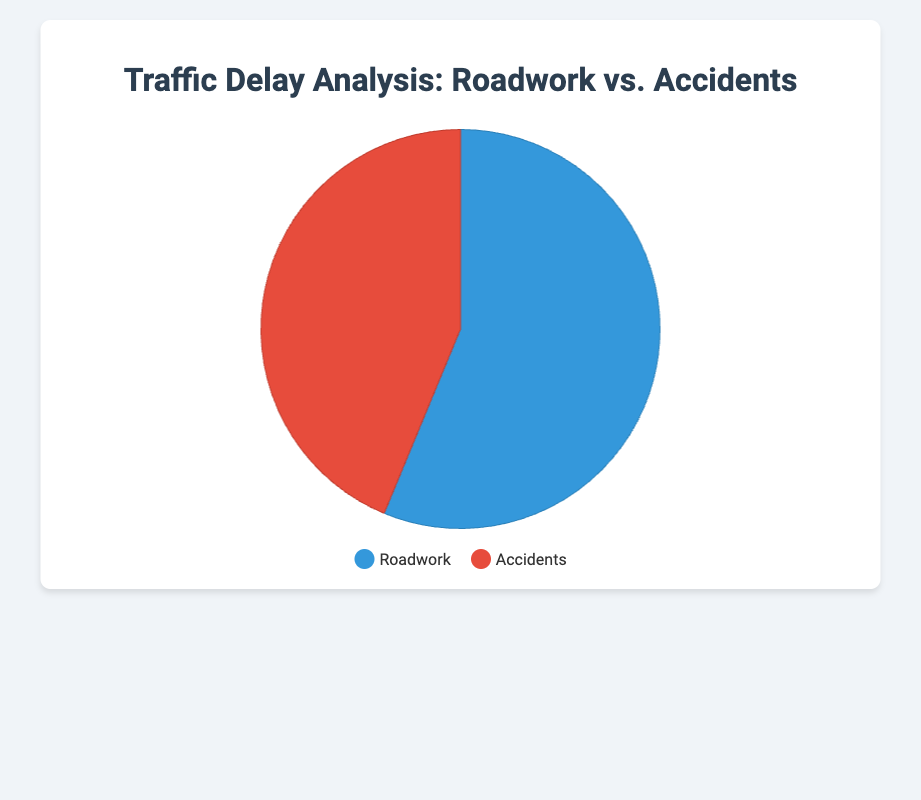What is the total delay caused by roadwork? To find the total delay caused by roadwork, you need to sum the durations for Los Angeles (45 minutes), Chicago (30 minutes), and New York (60 minutes). 45 + 30 + 60 = 135 minutes.
Answer: 135 minutes What is the percentage of delays caused by accidents? First, find the total delay for accidents by summing up the durations for Houston (20 minutes), Phoenix (35 minutes), and San Francisco (50 minutes). 20 + 35 + 50 = 105 minutes. Then, calculate the total delay by adding roadwork (135 minutes) and accidents (105 minutes). 135 + 105 = 240 minutes. Finally, divide the accident delay by the total delay and multiply by 100 to get the percentage: (105 / 240) * 100 = 43.75%.
Answer: 43.75% Which category of delay is larger, roadwork or accidents? Compare the total delays caused by roadwork (135 minutes) and accidents (105 minutes). Since 135 > 105, roadwork causes more delay than accidents.
Answer: Roadwork What is the difference in total delays between roadwork and accidents? Subtract the total delay caused by accidents (105 minutes) from the total delay caused by roadwork (135 minutes). 135 - 105 = 30 minutes.
Answer: 30 minutes If the delay in Phoenix due to an accident was reduced by 5 minutes, how would it affect the total delay caused by accidents? Currently, Phoenix contributes 35 minutes to the total accident delay. Reducing this by 5 minutes means Phoenix would contribute 30 minutes. The total delay for accidents would then be 20 (Houston) + 30 (Phoenix) + 50 (San Francisco) = 100 minutes.
Answer: 100 minutes How much longer is the delay caused by roadwork compared to the delay caused by accidents in terms of percentage? First, find the difference in delays: 135 minutes (roadwork) - 105 minutes (accidents) = 30 minutes. Then, divide this difference by the total delay for accidents and multiply by 100 to get the percentage. (30 / 105) * 100 ≈ 28.57%.
Answer: 28.57% Which city has the highest individual delay and from which category? Compare the durations for each city. Los Angeles (45 minutes, Roadwork), Chicago (30 minutes, Roadwork), New York (60 minutes, Roadwork), Houston (20 minutes, Accidents), Phoenix (35 minutes, Accidents), San Francisco (50 minutes, Accidents). New York has the highest delay at 60 minutes, under the Roadwork category.
Answer: New York, Roadwork If the proportions of delays caused by roadwork and accidents were equal, what would each delay duration be? The total duration for all delays is 240 minutes. If both categories had equal proportions, divide the total duration by 2. 240 / 2 = 120 minutes for each category.
Answer: 120 minutes each What is the average delay duration per incident for accidents and roadwork separately? Sum the total delays for accidents: 20 (Houston) + 35 (Phoenix) + 50 (San Francisco) = 105 minutes. Divide by the number of incidents (3) to get the average: 105 / 3 = 35 minutes. For roadwork, sum the delays: 45 (Los Angeles) + 30 (Chicago) + 60 (New York) = 135 minutes. Divide by the number of incidents (3) to get the average: 135 / 3 = 45 minutes.
Answer: 35 minutes (Accidents), 45 minutes (Roadwork) 